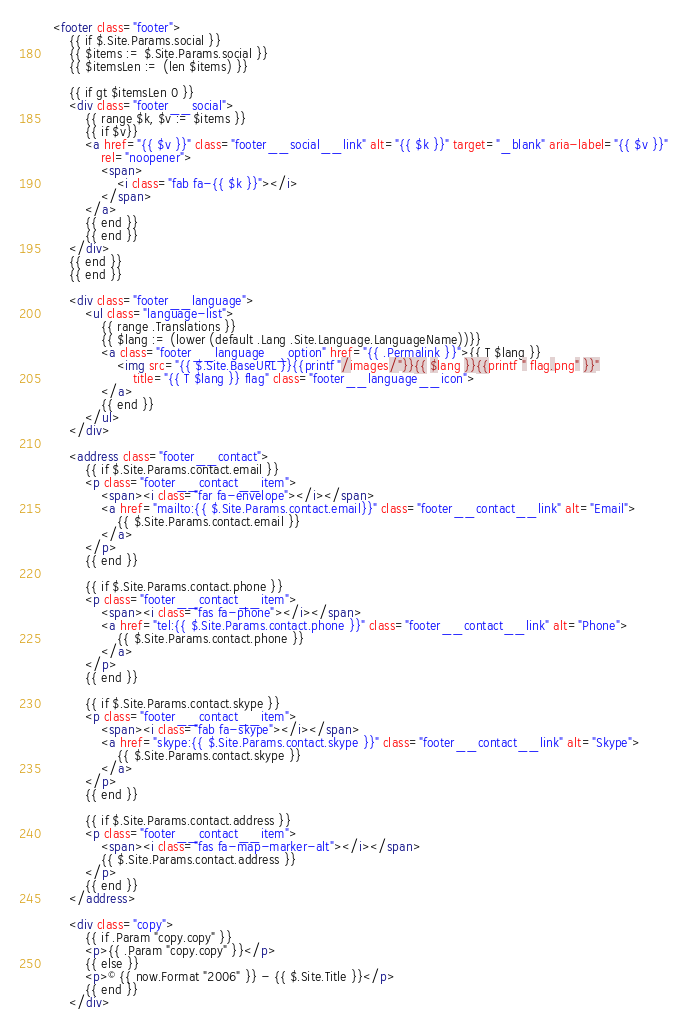Convert code to text. <code><loc_0><loc_0><loc_500><loc_500><_HTML_><footer class="footer">
    {{ if $.Site.Params.social }}
    {{ $items := $.Site.Params.social }}
    {{ $itemsLen := (len $items) }}

    {{ if gt $itemsLen 0 }}
    <div class="footer__social">
        {{ range $k, $v := $items }}
        {{ if $v}}
        <a href="{{ $v }}" class="footer__social__link" alt="{{ $k }}" target="_blank" aria-label="{{ $v }}"
            rel="noopener">
            <span>
                <i class="fab fa-{{ $k }}"></i>
            </span>
        </a>
        {{ end }}
        {{ end }}
    </div>
    {{ end }}
    {{ end }}

    <div class="footer__language">
        <ul class="language-list">
            {{ range .Translations }}
            {{ $lang := (lower (default .Lang .Site.Language.LanguageName))}}
            <a class="footer__language__option" href="{{ .Permalink }}">{{ T $lang }}
                <img src="{{ $.Site.BaseURL }}{{printf "/images/"}}{{ $lang }}{{printf " flag.png" }}"
                    title="{{ T $lang }} flag" class="footer__language__icon">
            </a>
            {{ end }}
        </ul>
    </div>

    <address class="footer__contact">
        {{ if $.Site.Params.contact.email }}
        <p class="footer__contact__item">
            <span><i class="far fa-envelope"></i></span>
            <a href="mailto:{{ $.Site.Params.contact.email}}" class="footer__contact__link" alt="Email">
                {{ $.Site.Params.contact.email }}
            </a>
        </p>
        {{ end }}

        {{ if $.Site.Params.contact.phone }}
        <p class="footer__contact__item">
            <span><i class="fas fa-phone"></i></span>
            <a href="tel:{{ $.Site.Params.contact.phone }}" class="footer__contact__link" alt="Phone">
                {{ $.Site.Params.contact.phone }}
            </a>
        </p>
        {{ end }}

        {{ if $.Site.Params.contact.skype }}
        <p class="footer__contact__item">
            <span><i class="fab fa-skype"></i></span>
            <a href="skype:{{ $.Site.Params.contact.skype }}" class="footer__contact__link" alt="Skype">
                {{ $.Site.Params.contact.skype }}
            </a>
        </p>
        {{ end }}

        {{ if $.Site.Params.contact.address }}
        <p class="footer__contact__item">
            <span><i class="fas fa-map-marker-alt"></i></span>
            {{ $.Site.Params.contact.address }}
        </p>
        {{ end }}
    </address>

    <div class="copy">
        {{ if .Param "copy.copy" }}
        <p>{{ .Param "copy.copy" }}</p>
        {{ else }}
        <p>© {{ now.Format "2006" }} - {{ $.Site.Title }}</p>
        {{ end }}
    </div>
</code> 